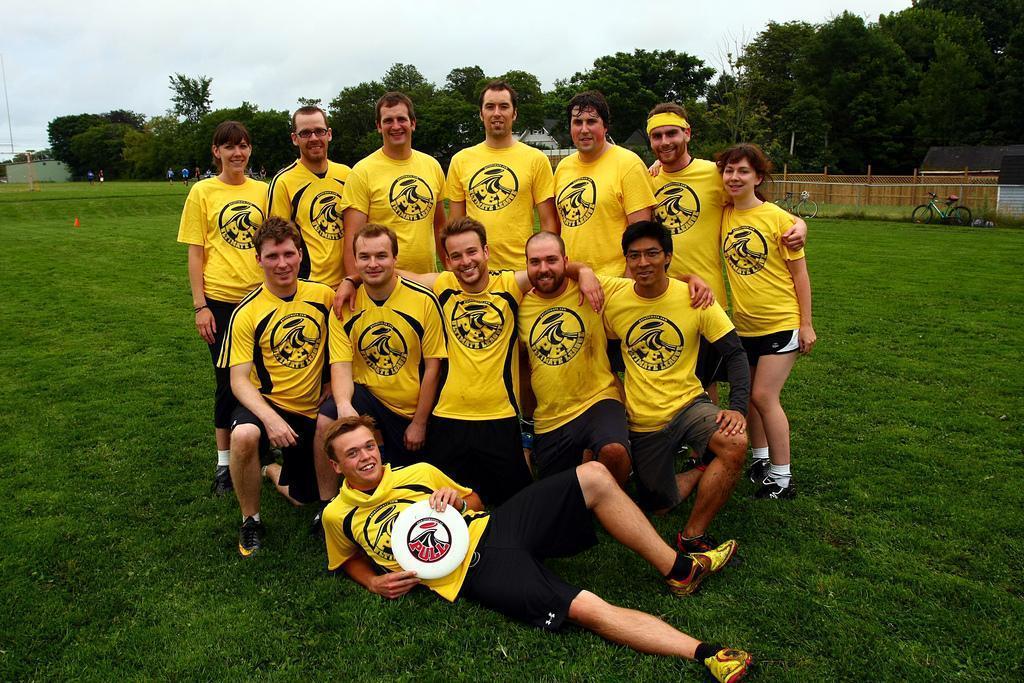How many men are kneeling together?
Give a very brief answer. 5. How many people are pictured?
Give a very brief answer. 13. How many females are shown?
Give a very brief answer. 2. How many members belong to the team?
Give a very brief answer. 13. How many females in the picture?
Give a very brief answer. 2. How many people wear a headband?
Give a very brief answer. 1. How many people lay on the ground?
Give a very brief answer. 1. How many people are lying down?
Give a very brief answer. 1. How many people are posing?
Give a very brief answer. 13. How many women players?
Give a very brief answer. 1. 